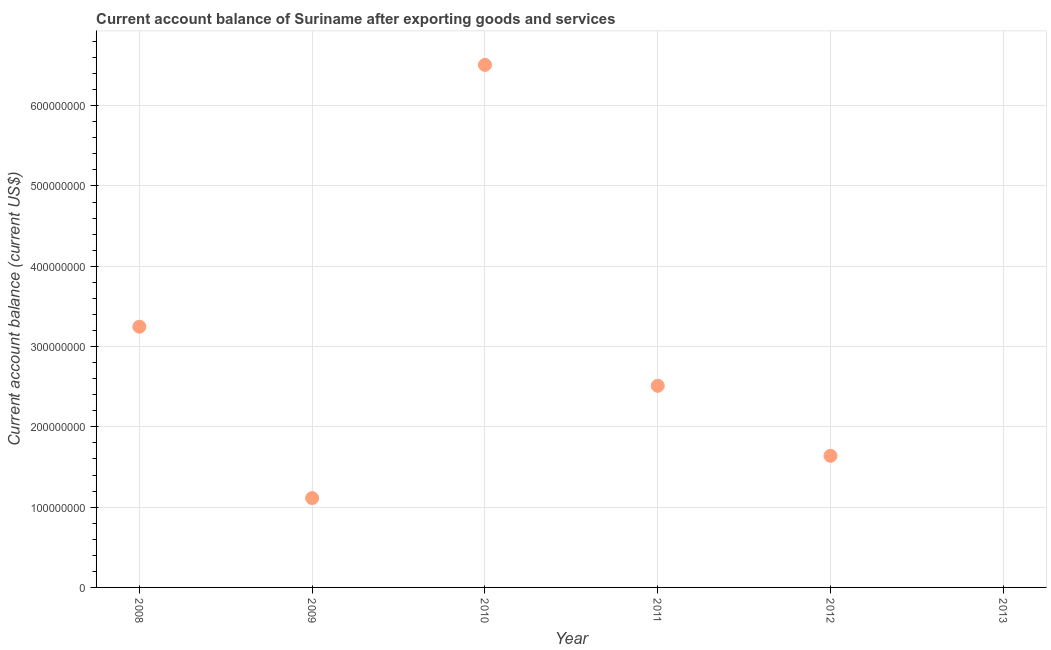What is the current account balance in 2011?
Offer a terse response. 2.51e+08. Across all years, what is the maximum current account balance?
Ensure brevity in your answer.  6.51e+08. What is the sum of the current account balance?
Ensure brevity in your answer.  1.50e+09. What is the difference between the current account balance in 2009 and 2010?
Offer a very short reply. -5.40e+08. What is the average current account balance per year?
Offer a very short reply. 2.50e+08. What is the median current account balance?
Ensure brevity in your answer.  2.08e+08. In how many years, is the current account balance greater than 600000000 US$?
Provide a succinct answer. 1. What is the ratio of the current account balance in 2009 to that in 2010?
Give a very brief answer. 0.17. What is the difference between the highest and the second highest current account balance?
Offer a terse response. 3.26e+08. Is the sum of the current account balance in 2009 and 2012 greater than the maximum current account balance across all years?
Give a very brief answer. No. What is the difference between the highest and the lowest current account balance?
Offer a very short reply. 6.51e+08. How many dotlines are there?
Keep it short and to the point. 1. Does the graph contain any zero values?
Ensure brevity in your answer.  Yes. Does the graph contain grids?
Give a very brief answer. Yes. What is the title of the graph?
Offer a very short reply. Current account balance of Suriname after exporting goods and services. What is the label or title of the Y-axis?
Give a very brief answer. Current account balance (current US$). What is the Current account balance (current US$) in 2008?
Keep it short and to the point. 3.25e+08. What is the Current account balance (current US$) in 2009?
Ensure brevity in your answer.  1.11e+08. What is the Current account balance (current US$) in 2010?
Provide a short and direct response. 6.51e+08. What is the Current account balance (current US$) in 2011?
Keep it short and to the point. 2.51e+08. What is the Current account balance (current US$) in 2012?
Offer a terse response. 1.64e+08. What is the Current account balance (current US$) in 2013?
Offer a very short reply. 0. What is the difference between the Current account balance (current US$) in 2008 and 2009?
Provide a succinct answer. 2.13e+08. What is the difference between the Current account balance (current US$) in 2008 and 2010?
Your answer should be very brief. -3.26e+08. What is the difference between the Current account balance (current US$) in 2008 and 2011?
Your answer should be compact. 7.36e+07. What is the difference between the Current account balance (current US$) in 2008 and 2012?
Keep it short and to the point. 1.61e+08. What is the difference between the Current account balance (current US$) in 2009 and 2010?
Your answer should be compact. -5.40e+08. What is the difference between the Current account balance (current US$) in 2009 and 2011?
Provide a short and direct response. -1.40e+08. What is the difference between the Current account balance (current US$) in 2009 and 2012?
Your response must be concise. -5.26e+07. What is the difference between the Current account balance (current US$) in 2010 and 2011?
Your answer should be compact. 4.00e+08. What is the difference between the Current account balance (current US$) in 2010 and 2012?
Provide a succinct answer. 4.87e+08. What is the difference between the Current account balance (current US$) in 2011 and 2012?
Your response must be concise. 8.72e+07. What is the ratio of the Current account balance (current US$) in 2008 to that in 2009?
Provide a succinct answer. 2.92. What is the ratio of the Current account balance (current US$) in 2008 to that in 2010?
Provide a short and direct response. 0.5. What is the ratio of the Current account balance (current US$) in 2008 to that in 2011?
Ensure brevity in your answer.  1.29. What is the ratio of the Current account balance (current US$) in 2008 to that in 2012?
Provide a short and direct response. 1.98. What is the ratio of the Current account balance (current US$) in 2009 to that in 2010?
Make the answer very short. 0.17. What is the ratio of the Current account balance (current US$) in 2009 to that in 2011?
Your answer should be very brief. 0.44. What is the ratio of the Current account balance (current US$) in 2009 to that in 2012?
Offer a very short reply. 0.68. What is the ratio of the Current account balance (current US$) in 2010 to that in 2011?
Give a very brief answer. 2.59. What is the ratio of the Current account balance (current US$) in 2010 to that in 2012?
Your answer should be compact. 3.97. What is the ratio of the Current account balance (current US$) in 2011 to that in 2012?
Provide a short and direct response. 1.53. 